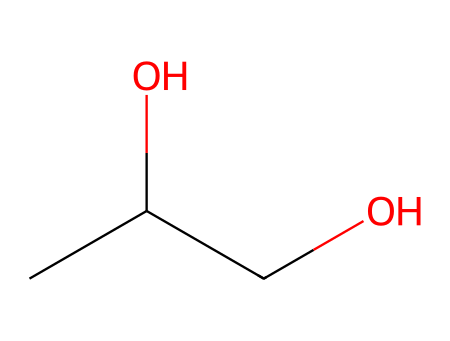What is the total number of carbon atoms in the chemical structure? The SMILES representation shows "CC(O)CO", which indicates there are two "C" atoms at the beginning, and one "C" connected to the "O". Counting these, we find there are a total of three carbon atoms.
Answer: three How many oxygen atoms are present in this chemical? In the SMILES representation "CC(O)CO", there is one "O" in the hydroxyl group and one "O" in the connection of the last "C" (the -COH part). Thus, there are a total of two oxygen atoms.
Answer: two What is the molecular formula for this chemical? The chemical structure has 3 carbon atoms (C), 8 hydrogen atoms (H), and 2 oxygen atoms (O). Therefore, the molecular formula is determined by counting each element and combining them to form C3H8O2.
Answer: C3H8O2 Does this compound contain functional groups? The SMILES indicates the presence of a hydroxyl group (-OH) due to the presence of "O" directly connected to a "C". Thus, the compound indeed has functional groups, specifically alcohols.
Answer: yes Is this chemical likely to be water-soluble? The presence of the hydroxyl (-OH) functional group typically increases polarity, suggesting that this chemical is likely to be soluble in water due to hydrogen bonding with water molecules.
Answer: yes How many stereocenters are present in this molecule? By examining the structure based on the SMILES, we find that there are no carbon atoms that have four different substituents. Thus, the molecule does not possess any stereocenters, indicating it is achiral.
Answer: zero What type of lipid is represented by this chemical? Given the structure and molecular formula, this compound is classified as a simple alcohol which can be part of the structure of certain lipids but does not represent a lipid itself. Therefore, it is related to lipid properties, but not a lipid type directly.
Answer: alcohol 